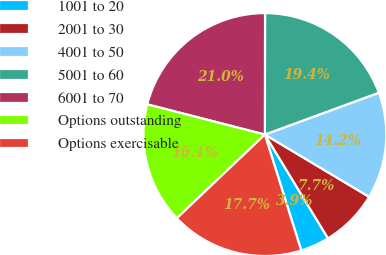Convert chart. <chart><loc_0><loc_0><loc_500><loc_500><pie_chart><fcel>1001 to 20<fcel>2001 to 30<fcel>4001 to 50<fcel>5001 to 60<fcel>6001 to 70<fcel>Options outstanding<fcel>Options exercisable<nl><fcel>3.86%<fcel>7.73%<fcel>14.17%<fcel>19.38%<fcel>21.02%<fcel>16.1%<fcel>17.74%<nl></chart> 